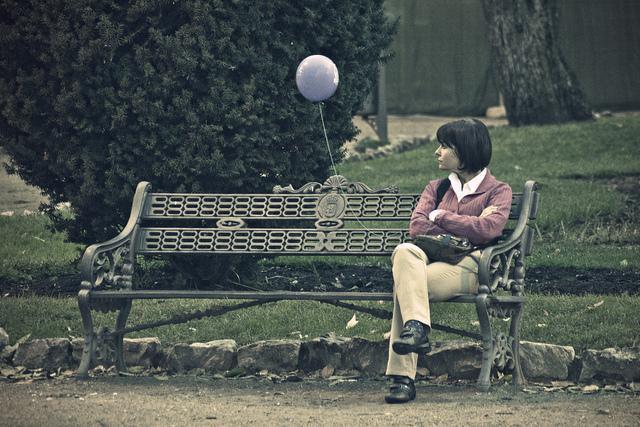What could pop that's attached to the bench?
Choose the correct response, then elucidate: 'Answer: answer
Rationale: rationale.'
Options: Bubble, balloon, tire, ball. Answer: balloon.
Rationale: That's the only thing that could pop. 